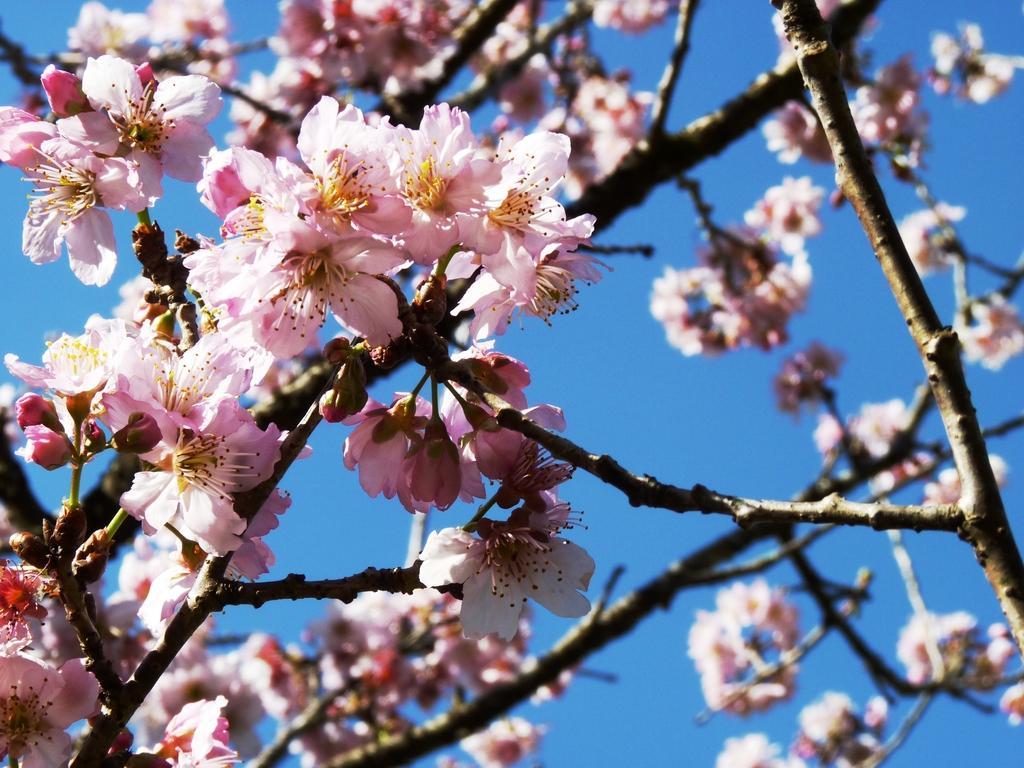Please provide a concise description of this image. In this image there are few stems having flowers and buds to it. Background there is sky. 